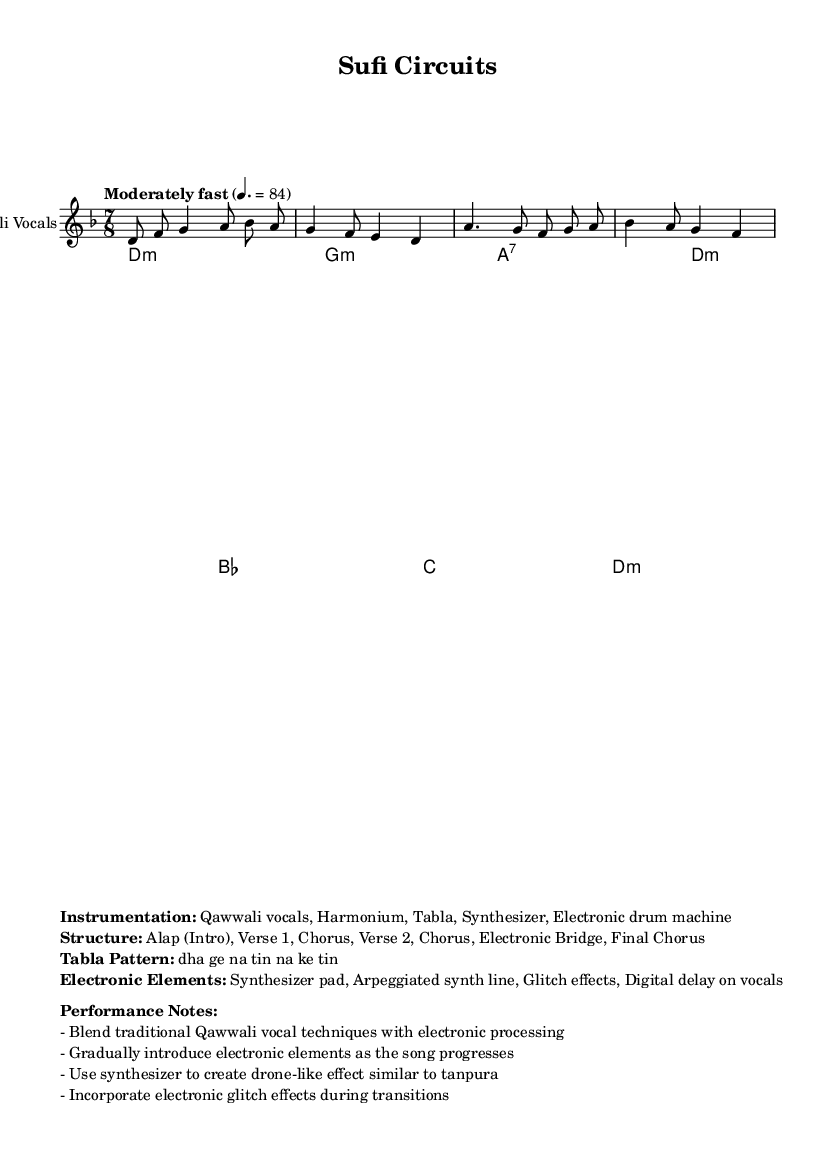What is the key signature of this music? The key signature is derived from the global section where it states \key d \minor, indicating that there are six flats in the key signature.
Answer: D minor What is the time signature of this music? The time signature is found in the global section, which specifies \time 7/8, indicating that there are seven eighth notes in each measure.
Answer: 7/8 What is the tempo of the piece? In the global section, the tempo is indicated as "Moderately fast" with a metronome marking of 4.=84, which tells us the speed at which the music should be played.
Answer: Moderately fast, 84 What are the main instruments used in this piece? The instrumentation is listed in the markup section of the code where it specifies "Qawwali vocals, Harmonium, Tabla, Synthesizer, Electronic drum machine." This provides a clear understanding of the instruments involved.
Answer: Qawwali vocals, Harmonium, Tabla, Synthesizer, Electronic drum machine Which section follows the second verse? From the structure outlined in the markup, the sequence is given: Alap, Verse 1, Chorus, Verse 2, and then it notes that the Electronic Bridge follows the second verse, indicating a transition into electronic music elements.
Answer: Electronic Bridge What tabla pattern is specified in the music? The tabla pattern is explicitly mentioned in the markup section, which identifies the rhythm as "dha ge na tin na ke tin," making it easy to identify the specific beat used in this piece.
Answer: dha ge na tin na ke tin What electronic elements are incorporated into this piece? The electronic elements are detailed in the markup section where it lists "Synthesizer pad, Arpeggiated synth line, Glitch effects, Digital delay on vocals," providing clear illustrative examples of how electronic sounds are integrated.
Answer: Synthesizer pad, Arpeggiated synth line, Glitch effects, Digital delay on vocals 